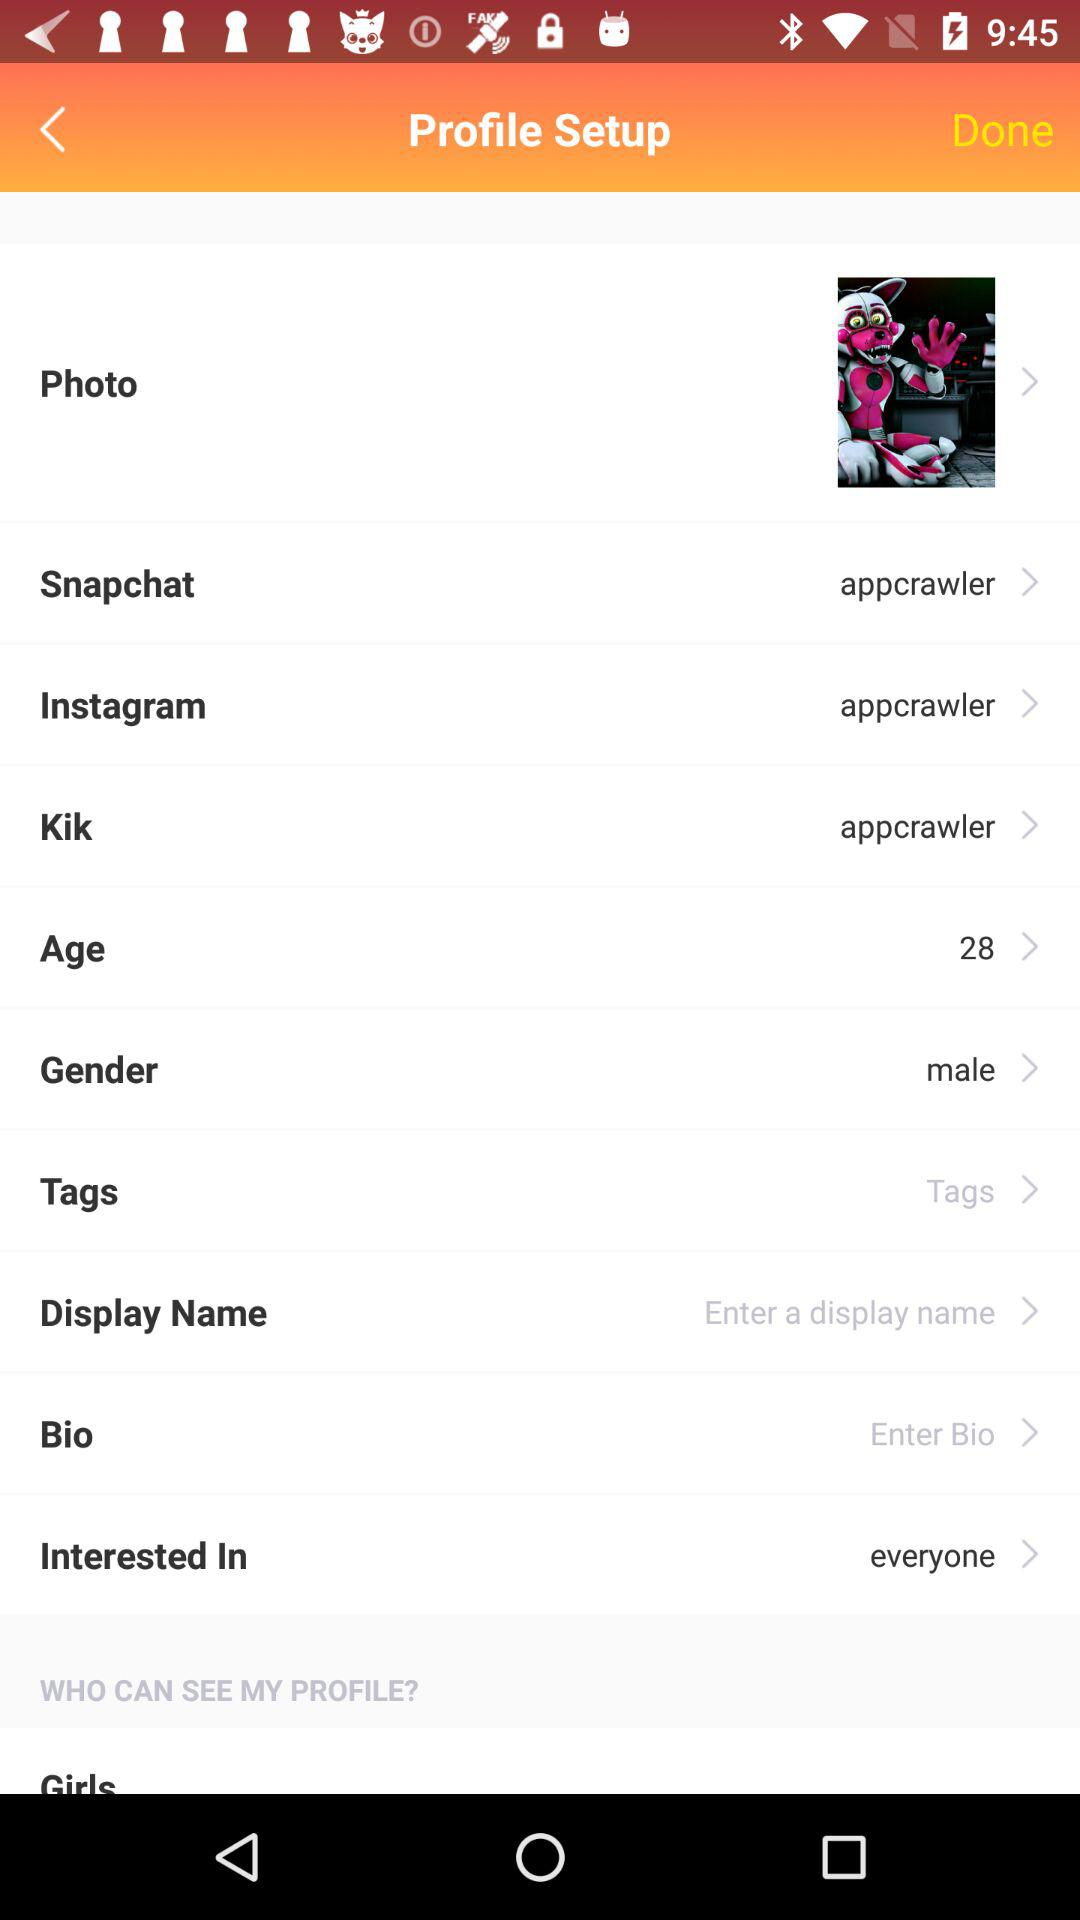What is the Instagram username? The Instagram username is "appcrawler". 